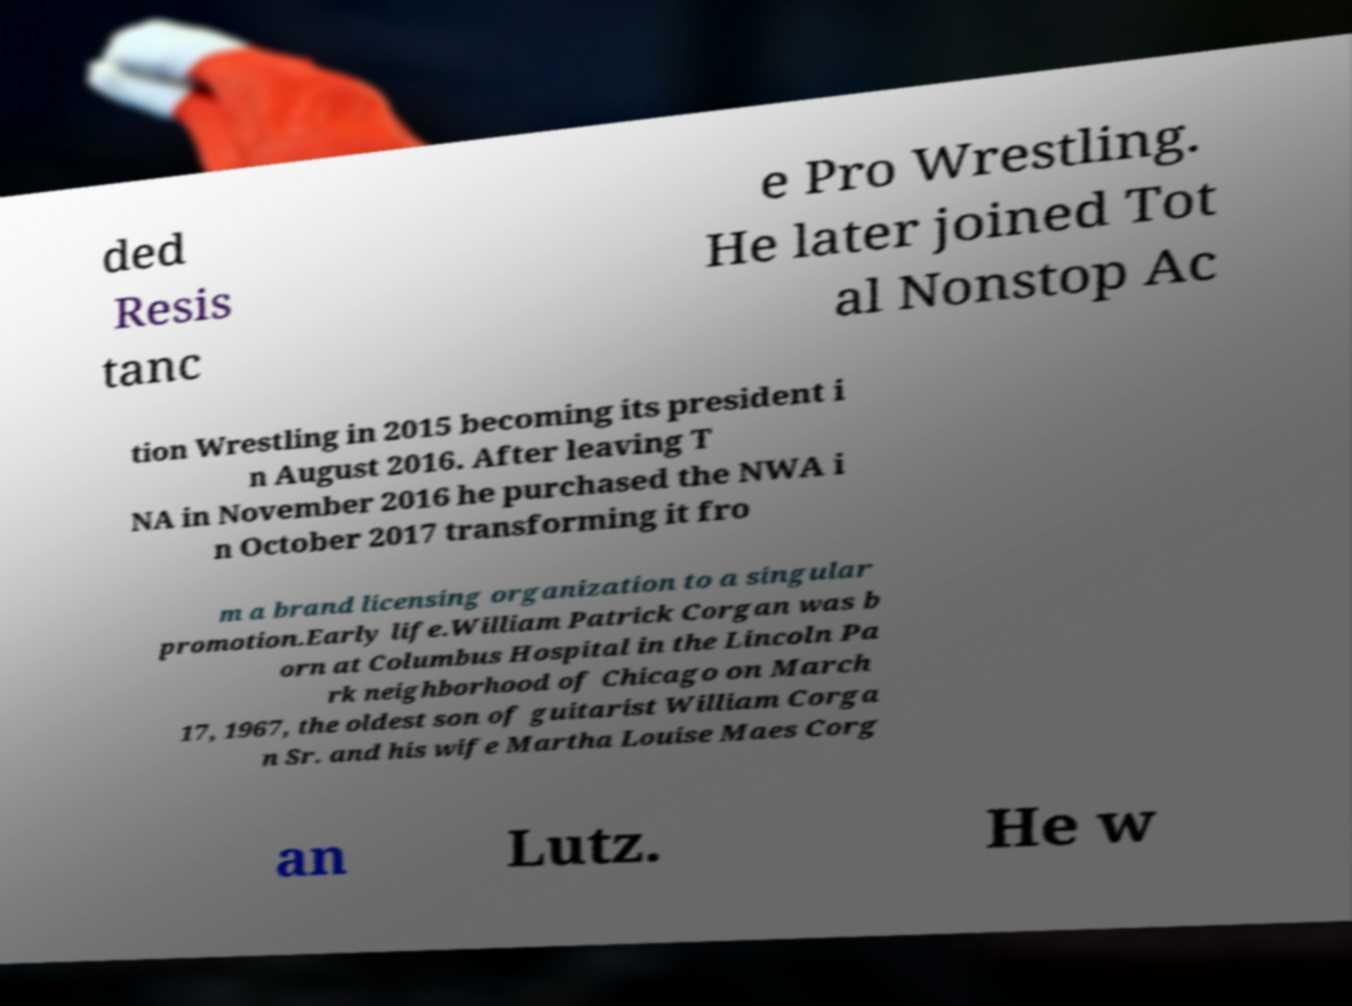For documentation purposes, I need the text within this image transcribed. Could you provide that? ded Resis tanc e Pro Wrestling. He later joined Tot al Nonstop Ac tion Wrestling in 2015 becoming its president i n August 2016. After leaving T NA in November 2016 he purchased the NWA i n October 2017 transforming it fro m a brand licensing organization to a singular promotion.Early life.William Patrick Corgan was b orn at Columbus Hospital in the Lincoln Pa rk neighborhood of Chicago on March 17, 1967, the oldest son of guitarist William Corga n Sr. and his wife Martha Louise Maes Corg an Lutz. He w 